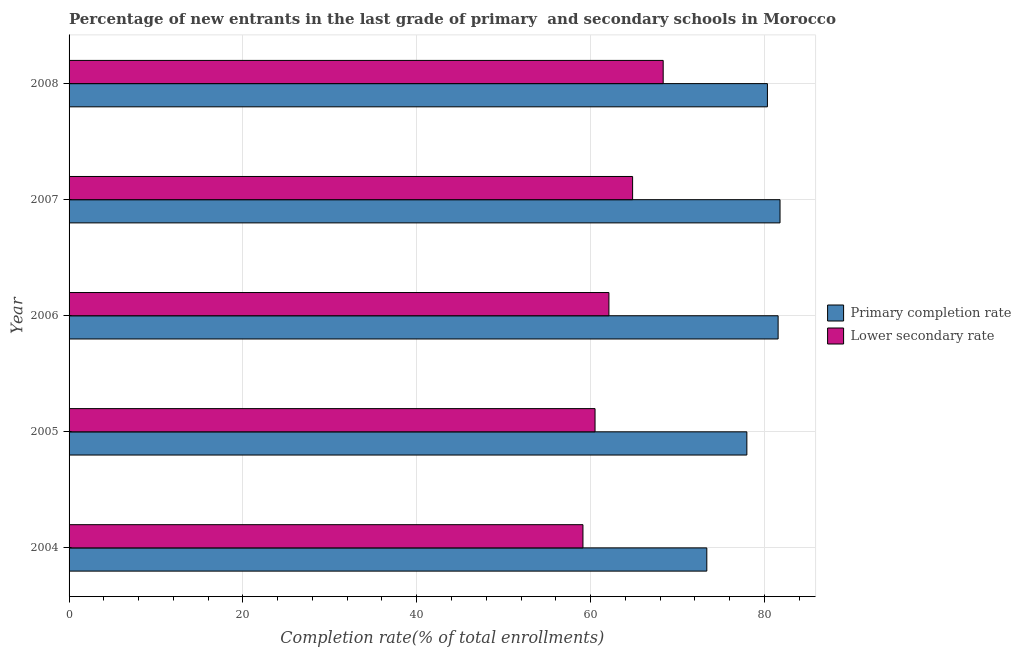How many different coloured bars are there?
Give a very brief answer. 2. How many groups of bars are there?
Make the answer very short. 5. Are the number of bars per tick equal to the number of legend labels?
Your response must be concise. Yes. Are the number of bars on each tick of the Y-axis equal?
Make the answer very short. Yes. How many bars are there on the 4th tick from the top?
Keep it short and to the point. 2. What is the label of the 1st group of bars from the top?
Your answer should be compact. 2008. In how many cases, is the number of bars for a given year not equal to the number of legend labels?
Keep it short and to the point. 0. What is the completion rate in primary schools in 2006?
Provide a short and direct response. 81.58. Across all years, what is the maximum completion rate in primary schools?
Make the answer very short. 81.8. Across all years, what is the minimum completion rate in secondary schools?
Give a very brief answer. 59.13. What is the total completion rate in secondary schools in the graph?
Make the answer very short. 314.96. What is the difference between the completion rate in secondary schools in 2004 and that in 2008?
Offer a terse response. -9.23. What is the difference between the completion rate in secondary schools in 2005 and the completion rate in primary schools in 2008?
Give a very brief answer. -19.83. What is the average completion rate in secondary schools per year?
Ensure brevity in your answer.  62.99. In the year 2008, what is the difference between the completion rate in secondary schools and completion rate in primary schools?
Offer a terse response. -11.99. What is the ratio of the completion rate in secondary schools in 2006 to that in 2007?
Your answer should be compact. 0.96. Is the completion rate in secondary schools in 2004 less than that in 2008?
Keep it short and to the point. Yes. What is the difference between the highest and the second highest completion rate in secondary schools?
Give a very brief answer. 3.52. What is the difference between the highest and the lowest completion rate in secondary schools?
Provide a short and direct response. 9.23. Is the sum of the completion rate in primary schools in 2005 and 2007 greater than the maximum completion rate in secondary schools across all years?
Provide a short and direct response. Yes. What does the 1st bar from the top in 2007 represents?
Your answer should be compact. Lower secondary rate. What does the 2nd bar from the bottom in 2006 represents?
Your response must be concise. Lower secondary rate. How many bars are there?
Ensure brevity in your answer.  10. Are all the bars in the graph horizontal?
Keep it short and to the point. Yes. Does the graph contain any zero values?
Your response must be concise. No. Does the graph contain grids?
Keep it short and to the point. Yes. How are the legend labels stacked?
Your response must be concise. Vertical. What is the title of the graph?
Offer a terse response. Percentage of new entrants in the last grade of primary  and secondary schools in Morocco. What is the label or title of the X-axis?
Your answer should be very brief. Completion rate(% of total enrollments). What is the Completion rate(% of total enrollments) in Primary completion rate in 2004?
Provide a short and direct response. 73.38. What is the Completion rate(% of total enrollments) in Lower secondary rate in 2004?
Provide a short and direct response. 59.13. What is the Completion rate(% of total enrollments) of Primary completion rate in 2005?
Provide a succinct answer. 77.99. What is the Completion rate(% of total enrollments) of Lower secondary rate in 2005?
Offer a very short reply. 60.52. What is the Completion rate(% of total enrollments) of Primary completion rate in 2006?
Your answer should be compact. 81.58. What is the Completion rate(% of total enrollments) of Lower secondary rate in 2006?
Your answer should be very brief. 62.12. What is the Completion rate(% of total enrollments) of Primary completion rate in 2007?
Your answer should be compact. 81.8. What is the Completion rate(% of total enrollments) in Lower secondary rate in 2007?
Offer a very short reply. 64.84. What is the Completion rate(% of total enrollments) of Primary completion rate in 2008?
Offer a terse response. 80.35. What is the Completion rate(% of total enrollments) in Lower secondary rate in 2008?
Ensure brevity in your answer.  68.36. Across all years, what is the maximum Completion rate(% of total enrollments) of Primary completion rate?
Make the answer very short. 81.8. Across all years, what is the maximum Completion rate(% of total enrollments) of Lower secondary rate?
Provide a succinct answer. 68.36. Across all years, what is the minimum Completion rate(% of total enrollments) in Primary completion rate?
Your response must be concise. 73.38. Across all years, what is the minimum Completion rate(% of total enrollments) of Lower secondary rate?
Your response must be concise. 59.13. What is the total Completion rate(% of total enrollments) of Primary completion rate in the graph?
Provide a short and direct response. 395.1. What is the total Completion rate(% of total enrollments) in Lower secondary rate in the graph?
Your response must be concise. 314.96. What is the difference between the Completion rate(% of total enrollments) in Primary completion rate in 2004 and that in 2005?
Your response must be concise. -4.61. What is the difference between the Completion rate(% of total enrollments) of Lower secondary rate in 2004 and that in 2005?
Your response must be concise. -1.39. What is the difference between the Completion rate(% of total enrollments) in Primary completion rate in 2004 and that in 2006?
Give a very brief answer. -8.21. What is the difference between the Completion rate(% of total enrollments) of Lower secondary rate in 2004 and that in 2006?
Ensure brevity in your answer.  -2.99. What is the difference between the Completion rate(% of total enrollments) of Primary completion rate in 2004 and that in 2007?
Ensure brevity in your answer.  -8.43. What is the difference between the Completion rate(% of total enrollments) of Lower secondary rate in 2004 and that in 2007?
Provide a short and direct response. -5.71. What is the difference between the Completion rate(% of total enrollments) in Primary completion rate in 2004 and that in 2008?
Your answer should be very brief. -6.98. What is the difference between the Completion rate(% of total enrollments) of Lower secondary rate in 2004 and that in 2008?
Keep it short and to the point. -9.23. What is the difference between the Completion rate(% of total enrollments) of Primary completion rate in 2005 and that in 2006?
Provide a succinct answer. -3.6. What is the difference between the Completion rate(% of total enrollments) of Lower secondary rate in 2005 and that in 2006?
Provide a succinct answer. -1.6. What is the difference between the Completion rate(% of total enrollments) of Primary completion rate in 2005 and that in 2007?
Make the answer very short. -3.82. What is the difference between the Completion rate(% of total enrollments) of Lower secondary rate in 2005 and that in 2007?
Offer a very short reply. -4.32. What is the difference between the Completion rate(% of total enrollments) of Primary completion rate in 2005 and that in 2008?
Your answer should be very brief. -2.37. What is the difference between the Completion rate(% of total enrollments) of Lower secondary rate in 2005 and that in 2008?
Your response must be concise. -7.84. What is the difference between the Completion rate(% of total enrollments) in Primary completion rate in 2006 and that in 2007?
Provide a short and direct response. -0.22. What is the difference between the Completion rate(% of total enrollments) in Lower secondary rate in 2006 and that in 2007?
Your answer should be very brief. -2.73. What is the difference between the Completion rate(% of total enrollments) in Primary completion rate in 2006 and that in 2008?
Your answer should be compact. 1.23. What is the difference between the Completion rate(% of total enrollments) in Lower secondary rate in 2006 and that in 2008?
Ensure brevity in your answer.  -6.24. What is the difference between the Completion rate(% of total enrollments) in Primary completion rate in 2007 and that in 2008?
Keep it short and to the point. 1.45. What is the difference between the Completion rate(% of total enrollments) of Lower secondary rate in 2007 and that in 2008?
Provide a succinct answer. -3.52. What is the difference between the Completion rate(% of total enrollments) of Primary completion rate in 2004 and the Completion rate(% of total enrollments) of Lower secondary rate in 2005?
Ensure brevity in your answer.  12.86. What is the difference between the Completion rate(% of total enrollments) of Primary completion rate in 2004 and the Completion rate(% of total enrollments) of Lower secondary rate in 2006?
Offer a terse response. 11.26. What is the difference between the Completion rate(% of total enrollments) in Primary completion rate in 2004 and the Completion rate(% of total enrollments) in Lower secondary rate in 2007?
Provide a succinct answer. 8.54. What is the difference between the Completion rate(% of total enrollments) in Primary completion rate in 2004 and the Completion rate(% of total enrollments) in Lower secondary rate in 2008?
Keep it short and to the point. 5.02. What is the difference between the Completion rate(% of total enrollments) in Primary completion rate in 2005 and the Completion rate(% of total enrollments) in Lower secondary rate in 2006?
Offer a terse response. 15.87. What is the difference between the Completion rate(% of total enrollments) in Primary completion rate in 2005 and the Completion rate(% of total enrollments) in Lower secondary rate in 2007?
Ensure brevity in your answer.  13.15. What is the difference between the Completion rate(% of total enrollments) in Primary completion rate in 2005 and the Completion rate(% of total enrollments) in Lower secondary rate in 2008?
Offer a terse response. 9.63. What is the difference between the Completion rate(% of total enrollments) of Primary completion rate in 2006 and the Completion rate(% of total enrollments) of Lower secondary rate in 2007?
Offer a terse response. 16.74. What is the difference between the Completion rate(% of total enrollments) in Primary completion rate in 2006 and the Completion rate(% of total enrollments) in Lower secondary rate in 2008?
Your response must be concise. 13.22. What is the difference between the Completion rate(% of total enrollments) in Primary completion rate in 2007 and the Completion rate(% of total enrollments) in Lower secondary rate in 2008?
Give a very brief answer. 13.44. What is the average Completion rate(% of total enrollments) of Primary completion rate per year?
Ensure brevity in your answer.  79.02. What is the average Completion rate(% of total enrollments) of Lower secondary rate per year?
Your answer should be very brief. 62.99. In the year 2004, what is the difference between the Completion rate(% of total enrollments) of Primary completion rate and Completion rate(% of total enrollments) of Lower secondary rate?
Your answer should be very brief. 14.25. In the year 2005, what is the difference between the Completion rate(% of total enrollments) of Primary completion rate and Completion rate(% of total enrollments) of Lower secondary rate?
Offer a very short reply. 17.47. In the year 2006, what is the difference between the Completion rate(% of total enrollments) of Primary completion rate and Completion rate(% of total enrollments) of Lower secondary rate?
Ensure brevity in your answer.  19.47. In the year 2007, what is the difference between the Completion rate(% of total enrollments) in Primary completion rate and Completion rate(% of total enrollments) in Lower secondary rate?
Keep it short and to the point. 16.96. In the year 2008, what is the difference between the Completion rate(% of total enrollments) in Primary completion rate and Completion rate(% of total enrollments) in Lower secondary rate?
Your answer should be very brief. 11.99. What is the ratio of the Completion rate(% of total enrollments) of Primary completion rate in 2004 to that in 2005?
Offer a terse response. 0.94. What is the ratio of the Completion rate(% of total enrollments) in Primary completion rate in 2004 to that in 2006?
Ensure brevity in your answer.  0.9. What is the ratio of the Completion rate(% of total enrollments) in Lower secondary rate in 2004 to that in 2006?
Offer a terse response. 0.95. What is the ratio of the Completion rate(% of total enrollments) of Primary completion rate in 2004 to that in 2007?
Provide a succinct answer. 0.9. What is the ratio of the Completion rate(% of total enrollments) of Lower secondary rate in 2004 to that in 2007?
Keep it short and to the point. 0.91. What is the ratio of the Completion rate(% of total enrollments) in Primary completion rate in 2004 to that in 2008?
Keep it short and to the point. 0.91. What is the ratio of the Completion rate(% of total enrollments) in Lower secondary rate in 2004 to that in 2008?
Ensure brevity in your answer.  0.86. What is the ratio of the Completion rate(% of total enrollments) of Primary completion rate in 2005 to that in 2006?
Give a very brief answer. 0.96. What is the ratio of the Completion rate(% of total enrollments) in Lower secondary rate in 2005 to that in 2006?
Ensure brevity in your answer.  0.97. What is the ratio of the Completion rate(% of total enrollments) in Primary completion rate in 2005 to that in 2007?
Offer a terse response. 0.95. What is the ratio of the Completion rate(% of total enrollments) of Primary completion rate in 2005 to that in 2008?
Your answer should be very brief. 0.97. What is the ratio of the Completion rate(% of total enrollments) of Lower secondary rate in 2005 to that in 2008?
Provide a short and direct response. 0.89. What is the ratio of the Completion rate(% of total enrollments) in Primary completion rate in 2006 to that in 2007?
Ensure brevity in your answer.  1. What is the ratio of the Completion rate(% of total enrollments) in Lower secondary rate in 2006 to that in 2007?
Your answer should be compact. 0.96. What is the ratio of the Completion rate(% of total enrollments) in Primary completion rate in 2006 to that in 2008?
Give a very brief answer. 1.02. What is the ratio of the Completion rate(% of total enrollments) of Lower secondary rate in 2006 to that in 2008?
Your answer should be compact. 0.91. What is the ratio of the Completion rate(% of total enrollments) in Primary completion rate in 2007 to that in 2008?
Provide a succinct answer. 1.02. What is the ratio of the Completion rate(% of total enrollments) in Lower secondary rate in 2007 to that in 2008?
Offer a terse response. 0.95. What is the difference between the highest and the second highest Completion rate(% of total enrollments) in Primary completion rate?
Your answer should be compact. 0.22. What is the difference between the highest and the second highest Completion rate(% of total enrollments) in Lower secondary rate?
Your response must be concise. 3.52. What is the difference between the highest and the lowest Completion rate(% of total enrollments) of Primary completion rate?
Your answer should be very brief. 8.43. What is the difference between the highest and the lowest Completion rate(% of total enrollments) of Lower secondary rate?
Offer a very short reply. 9.23. 